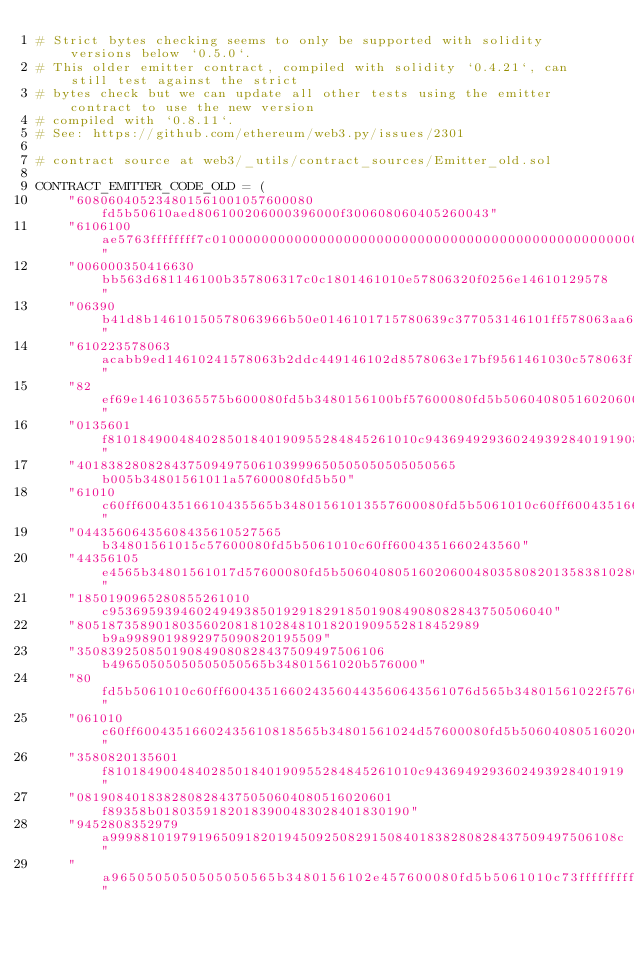Convert code to text. <code><loc_0><loc_0><loc_500><loc_500><_Python_># Strict bytes checking seems to only be supported with solidity versions below `0.5.0`.
# This older emitter contract, compiled with solidity `0.4.21`, can still test against the strict
# bytes check but we can update all other tests using the emitter contract to use the new version
# compiled with `0.8.11`.
# See: https://github.com/ethereum/web3.py/issues/2301

# contract source at web3/_utils/contract_sources/Emitter_old.sol

CONTRACT_EMITTER_CODE_OLD = (
    "608060405234801561001057600080fd5b50610aed806100206000396000f300608060405260043"
    "6106100ae5763ffffffff7c01000000000000000000000000000000000000000000000000000000"
    "006000350416630bb563d681146100b357806317c0c1801461010e57806320f0256e14610129578"
    "06390b41d8b14610150578063966b50e0146101715780639c377053146101ff578063aa6fd82214"
    "610223578063acabb9ed14610241578063b2ddc449146102d8578063e17bf9561461030c578063f"
    "82ef69e14610365575b600080fd5b3480156100bf57600080fd5b50604080516020600480358082"
    "0135601f810184900484028501840190955284845261010c9436949293602493928401919081908"
    "401838280828437509497506103999650505050505050565b005b34801561011a57600080fd5b50"
    "61010c60ff60043516610435565b34801561013557600080fd5b5061010c60ff600435166024356"
    "04435606435608435610527565b34801561015c57600080fd5b5061010c60ff6004351660243560"
    "44356105e4565b34801561017d57600080fd5b50604080516020600480358082013583810280860"
    "1850190965280855261010c95369593946024949385019291829185019084908082843750506040"
    "805187358901803560208181028481018201909552818452989b9a9989019892975090820195509"
    "350839250850190849080828437509497506106b49650505050505050565b34801561020b576000"
    "80fd5b5061010c60ff6004351660243560443560643561076d565b34801561022f57600080fd5b5"
    "061010c60ff60043516602435610818565b34801561024d57600080fd5b50604080516020600480"
    "3580820135601f810184900484028501840190955284845261010c9436949293602493928401919"
    "0819084018382808284375050604080516020601f89358b01803591820183900483028401830190"
    "9452808352979a9998810197919650918201945092508291508401838280828437509497506108c"
    "a9650505050505050565b3480156102e457600080fd5b5061010c73ffffffffffffffffffffffff"</code> 